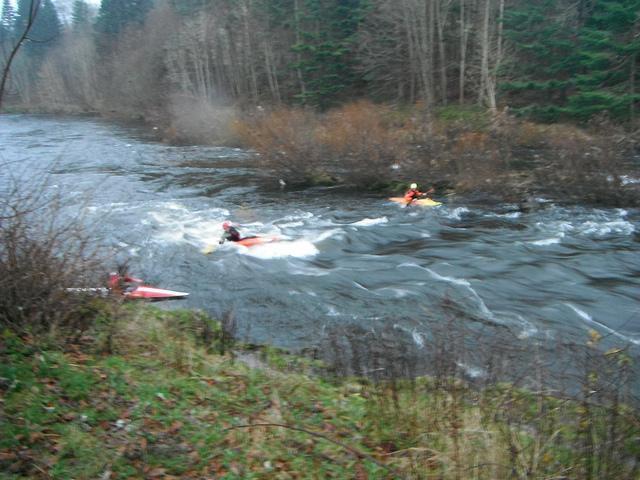How many giraffes are shorter that the lamp post?
Give a very brief answer. 0. 